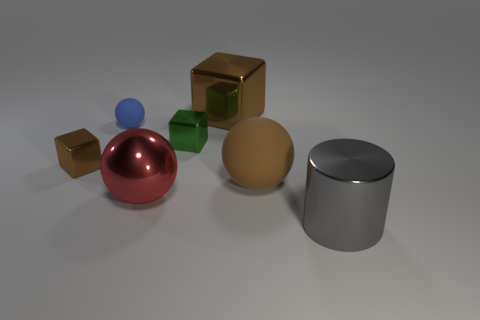What number of things are big balls that are to the left of the small green shiny cube or objects that are to the left of the large gray thing?
Give a very brief answer. 6. What is the shape of the object in front of the big ball in front of the big brown rubber sphere?
Give a very brief answer. Cylinder. Is there any other thing of the same color as the small rubber object?
Offer a terse response. No. What number of objects are either tiny blocks or big cubes?
Provide a short and direct response. 3. Are there any brown balls of the same size as the red ball?
Ensure brevity in your answer.  Yes. There is a large brown matte thing; what shape is it?
Your response must be concise. Sphere. Are there more brown spheres behind the cylinder than small blue spheres that are in front of the red object?
Make the answer very short. Yes. Does the small block left of the large red metal thing have the same color as the large metal thing that is behind the green metal object?
Your answer should be compact. Yes. The metal thing that is the same size as the green cube is what shape?
Offer a terse response. Cube. Is there another small brown shiny object that has the same shape as the tiny brown shiny thing?
Keep it short and to the point. No. 